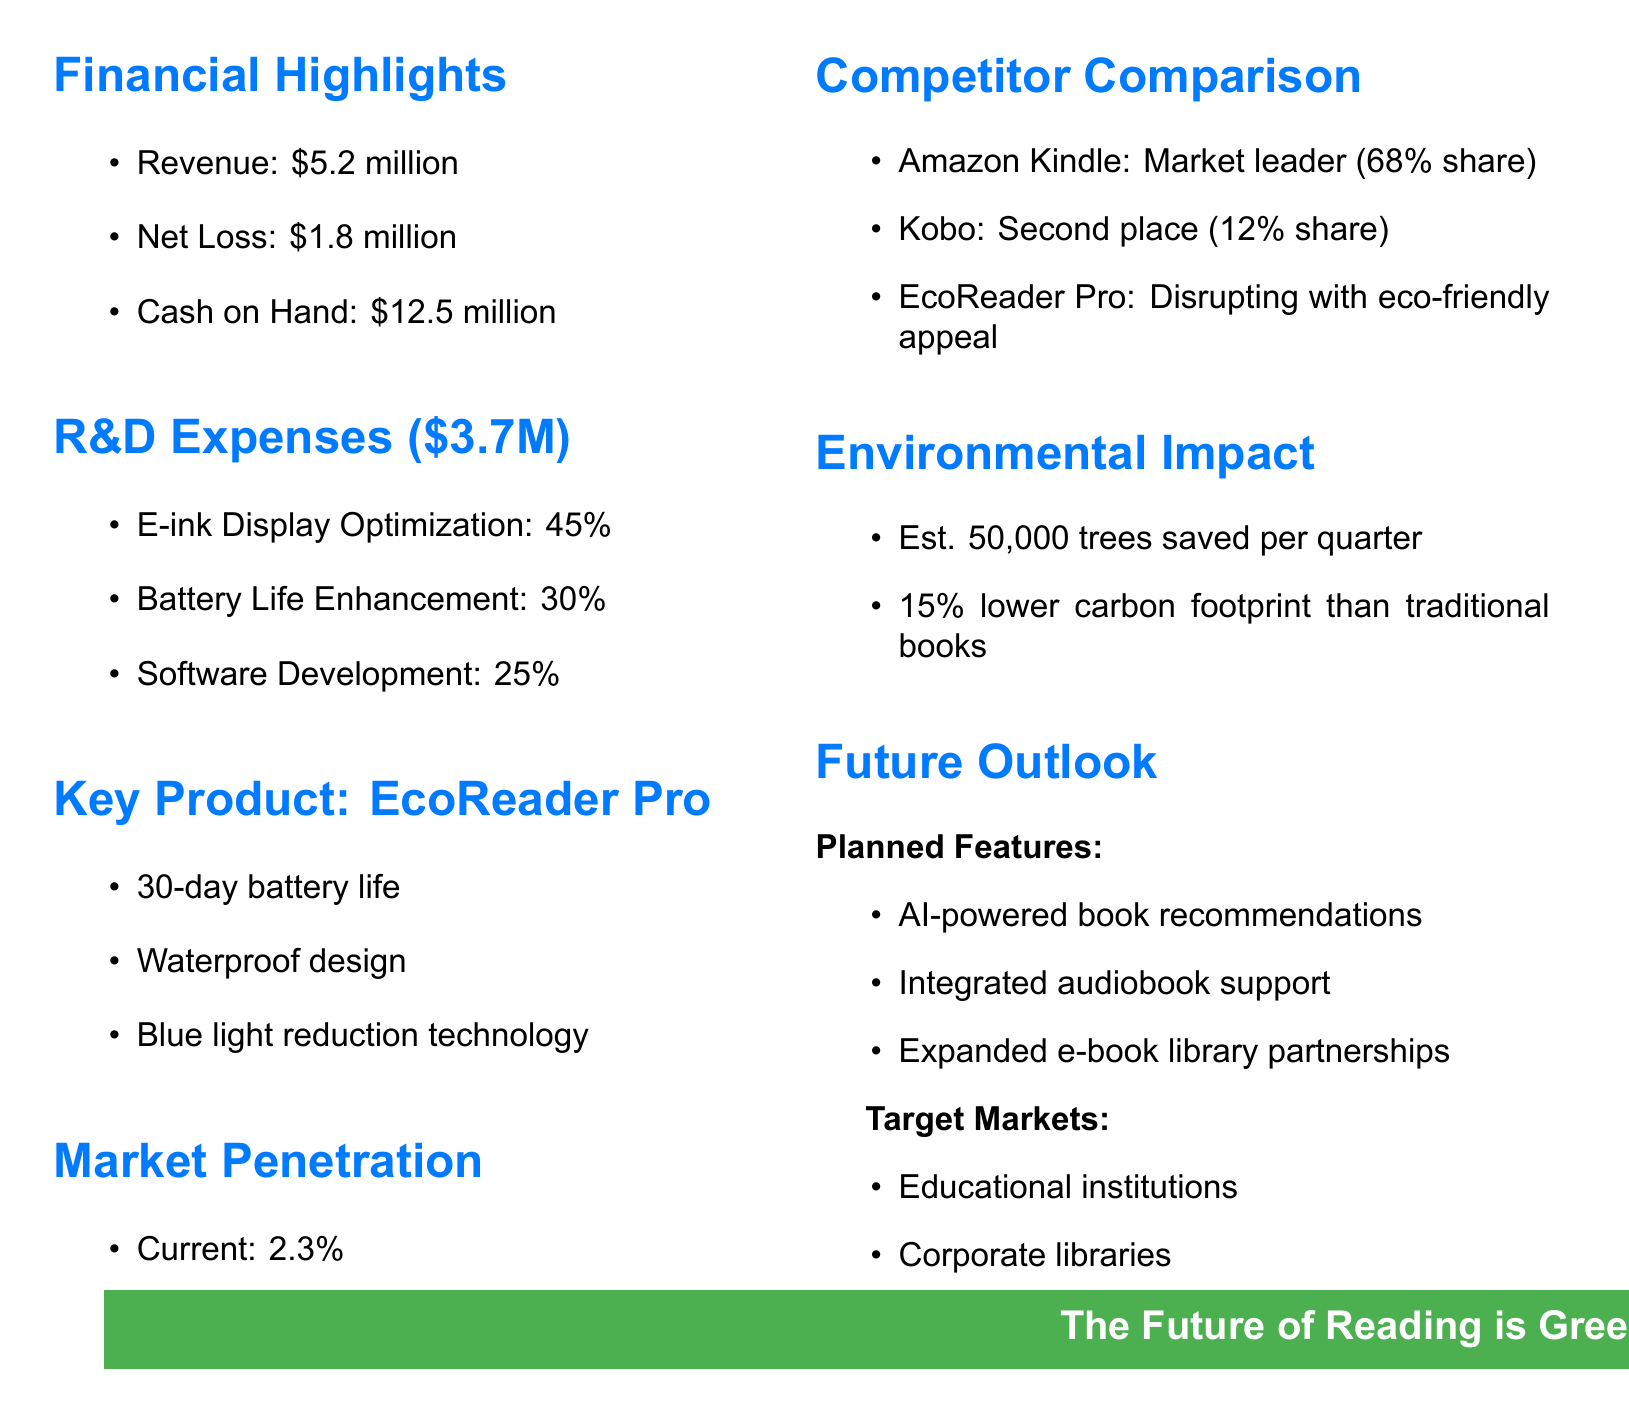What is the total revenue for Q3 2023? The total revenue for Q3 2023 is stated in the financial highlights section.
Answer: $5.2 million What are the R&D expenses for InnoRead Technologies? The total R&D expenses are detailed in the R&D Expenses section of the document.
Answer: $3.7 million What feature of the EcoReader Pro enhances user comfort? The feature that enhances user comfort is mentioned in the Key Product section.
Answer: Blue light reduction technology What is the projected market penetration for the end of the year? The projected market penetration is listed under Market Penetration.
Answer: 4.5% How much cash does InnoRead Technologies have on hand? The amount of cash on hand is included in the financial highlights.
Answer: $12.5 million What percentage of R&D expenses is allocated to battery life enhancement? The percentage allocation for battery life enhancement is found in the R&D Expenses section.
Answer: 30% Which competitor holds the largest market share? The competitor with the largest market share is mentioned in Competitor Comparison.
Answer: Amazon Kindle What is the estimated number of trees saved per quarter? The estimated number of trees saved is included in the Environmental Impact section.
Answer: 50,000 trees What target market category includes eco-conscious consumers? The target market including eco-conscious consumers is specified in the Future Outlook section.
Answer: Eco-conscious consumers 